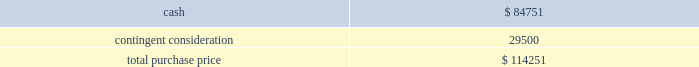Table of contents the company concluded that the acquisition of sentinelle medical did not represent a material business combination , and therefore , no pro forma financial information has been provided herein .
Subsequent to the acquisition date , the company 2019s results of operations include the results of sentinelle medical , which is included within the company 2019s breast health reporting segment .
The company accounted for the sentinelle medical acquisition as a purchase of a business under asc 805 .
The purchase price was comprised of an $ 84.8 million cash payment , which was net of certain adjustments , plus three contingent payments up to a maximum of an additional $ 250.0 million in cash .
The contingent payments are based on a multiple of incremental revenue growth during the two-year period following the completion of the acquisition as follows : six months after acquisition , 12 months after acquisition , and 24 months after acquisition .
Pursuant to asc 805 , the company recorded its estimate of the fair value of the contingent consideration liability based on future revenue projections of the sentinelle medical business under various potential scenarios and weighted probability assumptions of these outcomes .
As of the date of acquisition , these cash flow projections were discounted using a rate of 16.5% ( 16.5 % ) .
The discount rate is based on the weighted-average cost of capital of the acquired business plus a credit risk premium for non-performance risk related to the liability pursuant to asc 820 .
This analysis resulted in an initial contingent consideration liability of $ 29.5 million , which will be adjusted periodically as a component of operating expenses based on changes in the fair value of the liability driven by the accretion of the liability for the time value of money and changes in the assumptions pertaining to the achievement of the defined revenue growth milestones .
This fair value measurement was based on significant inputs not observable in the market and thus represented a level 3 measurement as defined in asc during each quarter in fiscal 2011 , the company has re-evaluated its assumptions and updated the revenue and probability assumptions for future earn-out periods and lowered its projections .
As a result of these adjustments , which were partially offset by the accretion of the liability , and using a current discount rate of approximately 17.0% ( 17.0 % ) , the company recorded a reversal of expense of $ 14.3 million in fiscal 2011 to record the contingent consideration liability at fair value .
In addition , during the second quarter of fiscal 2011 , the first earn-out period ended , and the company adjusted the fair value of the contingent consideration liability for actual results during the earn-out period .
This payment of $ 4.3 million was made in the third quarter of fiscal 2011 .
At september 24 , 2011 , the fair value of the liability is $ 10.9 million .
The company did not issue any equity awards in connection with this acquisition .
The company incurred third-party transaction costs of $ 1.2 million , which were expensed within general and administrative expenses in fiscal 2010 .
The purchase price was as follows: .
Source : hologic inc , 10-k , november 23 , 2011 powered by morningstar ae document research 2120 the information contained herein may not be copied , adapted or distributed and is not warranted to be accurate , complete or timely .
The user assumes all risks for any damages or losses arising from any use of this information , except to the extent such damages or losses cannot be limited or excluded by applicable law .
Past financial performance is no guarantee of future results. .
What was the total purchase price in cash payment for the sentinelle medical acquisition? 
Rationale: in line 4 it states that the company paid 3 amounts of 250 and therefore you would multiple that amount by 3 and then add up the initial payment .
Computations: (84.8 + (250.0 * 3))
Answer: 834.8. 